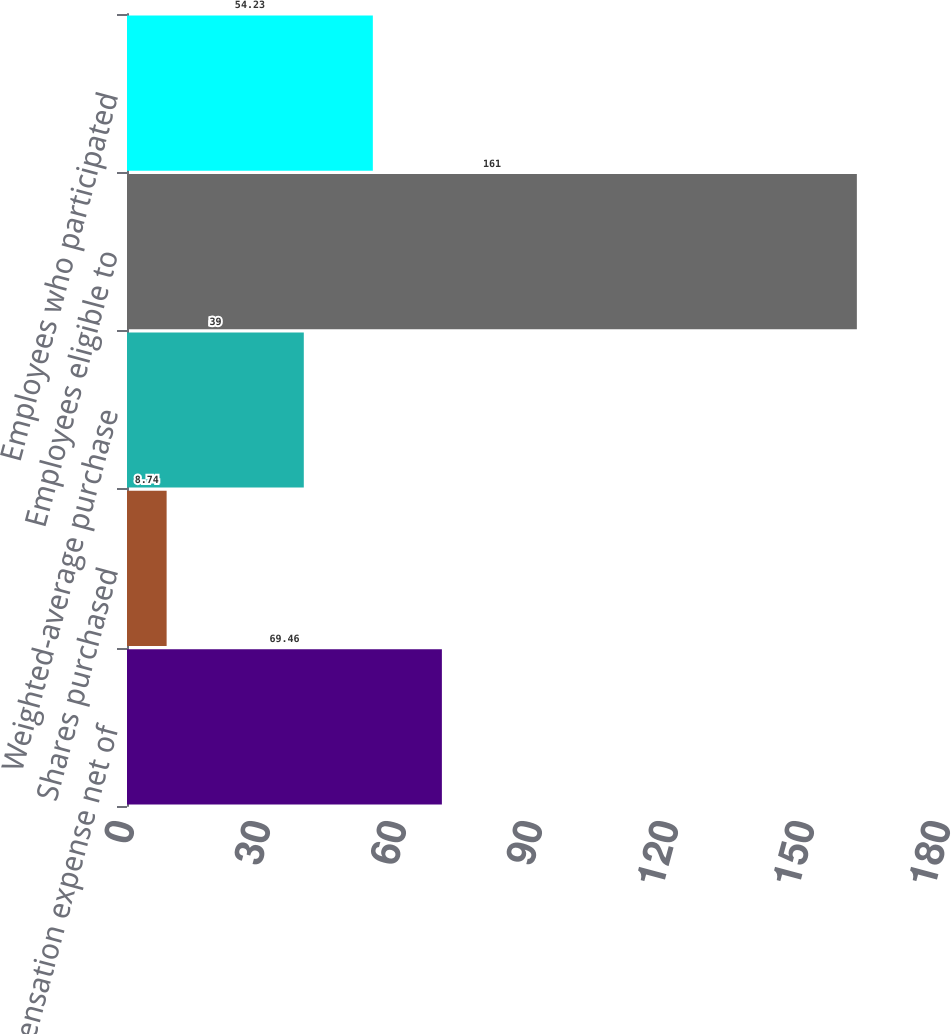<chart> <loc_0><loc_0><loc_500><loc_500><bar_chart><fcel>Compensation expense net of<fcel>Shares purchased<fcel>Weighted-average purchase<fcel>Employees eligible to<fcel>Employees who participated<nl><fcel>69.46<fcel>8.74<fcel>39<fcel>161<fcel>54.23<nl></chart> 